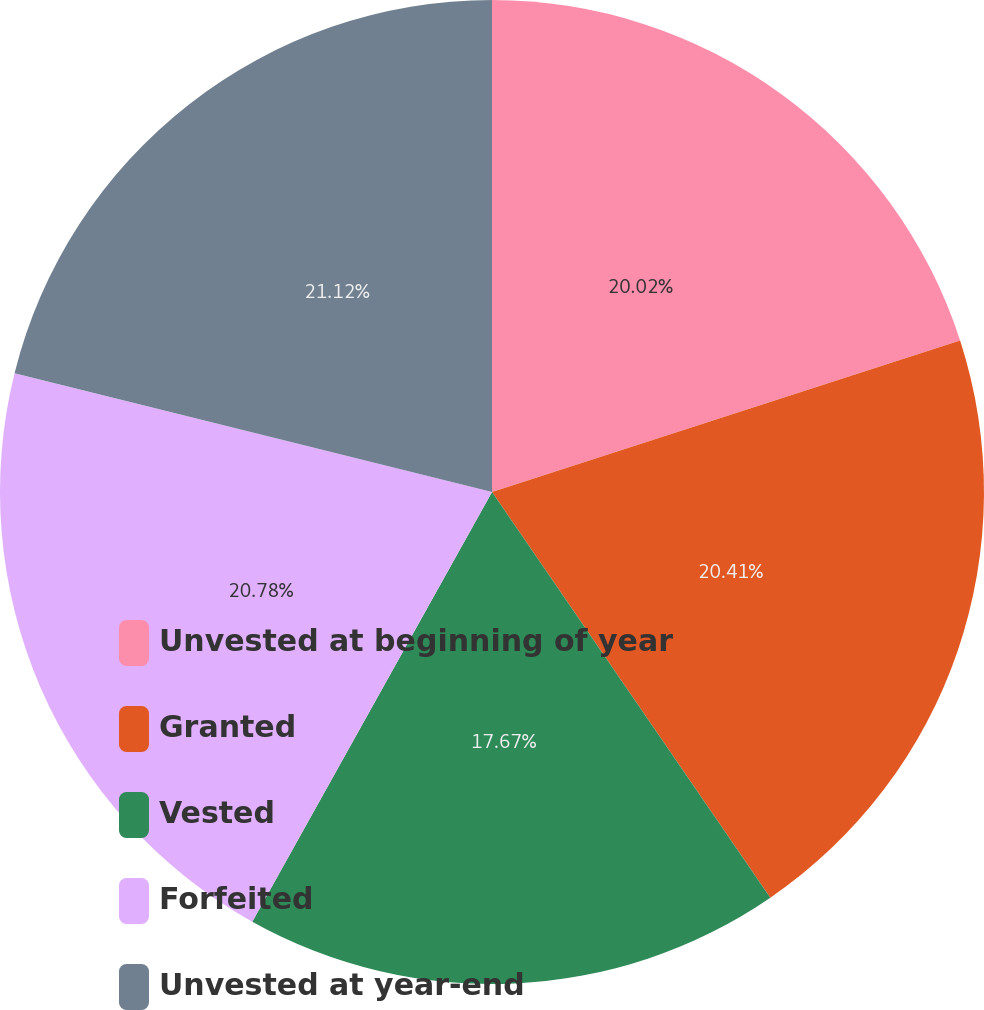Convert chart. <chart><loc_0><loc_0><loc_500><loc_500><pie_chart><fcel>Unvested at beginning of year<fcel>Granted<fcel>Vested<fcel>Forfeited<fcel>Unvested at year-end<nl><fcel>20.02%<fcel>20.41%<fcel>17.67%<fcel>20.78%<fcel>21.12%<nl></chart> 